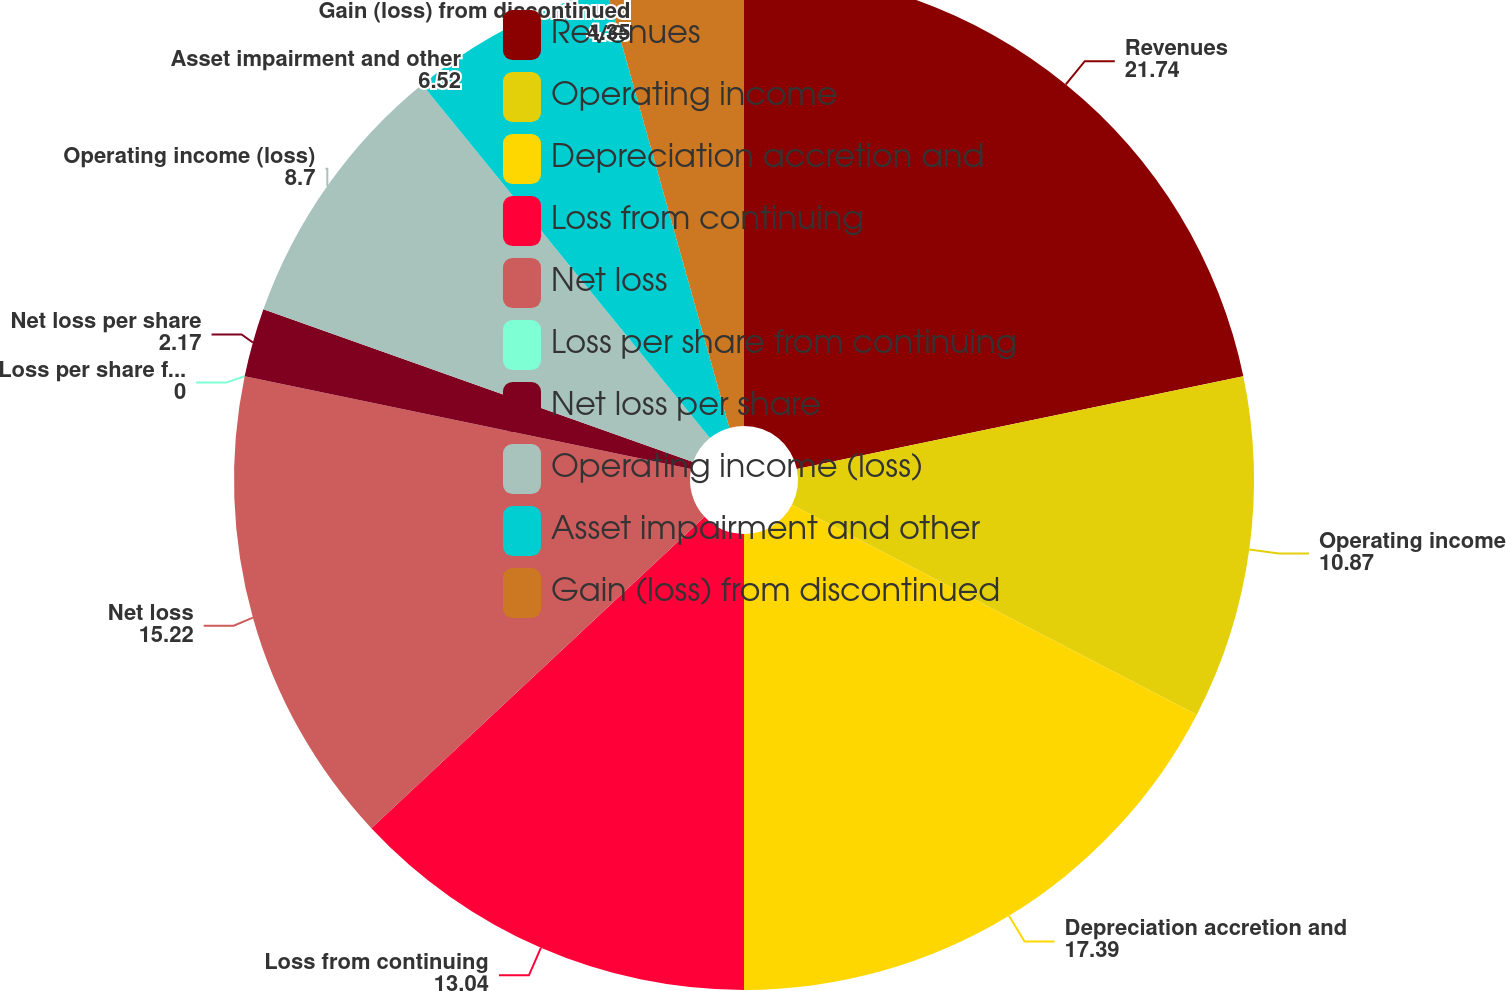Convert chart. <chart><loc_0><loc_0><loc_500><loc_500><pie_chart><fcel>Revenues<fcel>Operating income<fcel>Depreciation accretion and<fcel>Loss from continuing<fcel>Net loss<fcel>Loss per share from continuing<fcel>Net loss per share<fcel>Operating income (loss)<fcel>Asset impairment and other<fcel>Gain (loss) from discontinued<nl><fcel>21.74%<fcel>10.87%<fcel>17.39%<fcel>13.04%<fcel>15.22%<fcel>0.0%<fcel>2.17%<fcel>8.7%<fcel>6.52%<fcel>4.35%<nl></chart> 